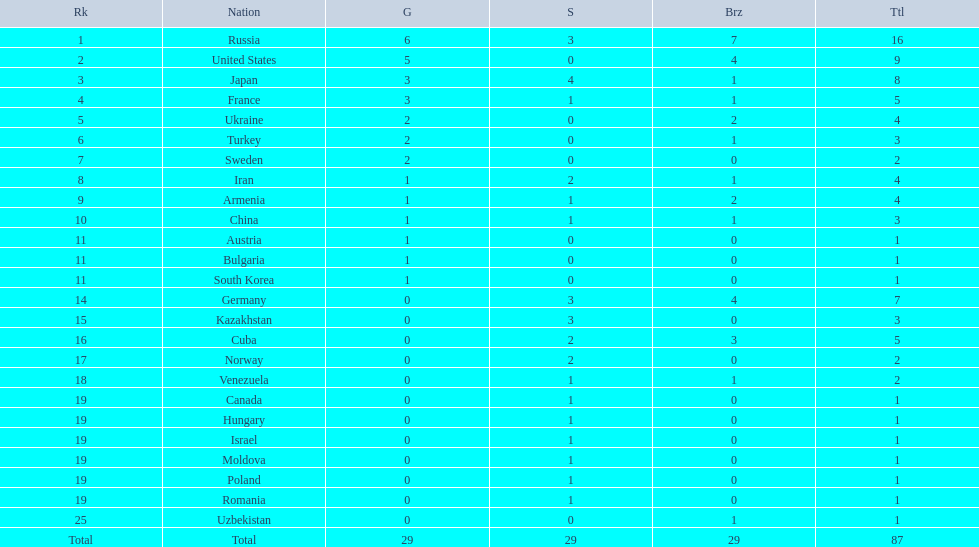What were the nations that participated in the 1995 world wrestling championships? Russia, United States, Japan, France, Ukraine, Turkey, Sweden, Iran, Armenia, China, Austria, Bulgaria, South Korea, Germany, Kazakhstan, Cuba, Norway, Venezuela, Canada, Hungary, Israel, Moldova, Poland, Romania, Uzbekistan. How many gold medals did the united states earn in the championship? 5. What amount of medals earner was greater than this value? 6. What country earned these medals? Russia. 